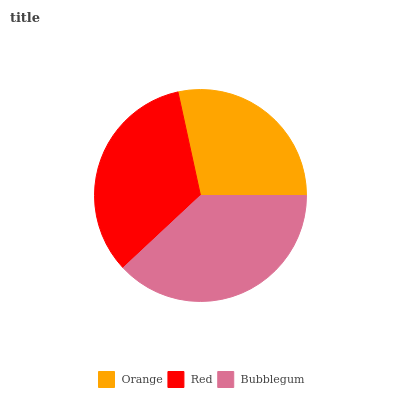Is Orange the minimum?
Answer yes or no. Yes. Is Bubblegum the maximum?
Answer yes or no. Yes. Is Red the minimum?
Answer yes or no. No. Is Red the maximum?
Answer yes or no. No. Is Red greater than Orange?
Answer yes or no. Yes. Is Orange less than Red?
Answer yes or no. Yes. Is Orange greater than Red?
Answer yes or no. No. Is Red less than Orange?
Answer yes or no. No. Is Red the high median?
Answer yes or no. Yes. Is Red the low median?
Answer yes or no. Yes. Is Bubblegum the high median?
Answer yes or no. No. Is Bubblegum the low median?
Answer yes or no. No. 